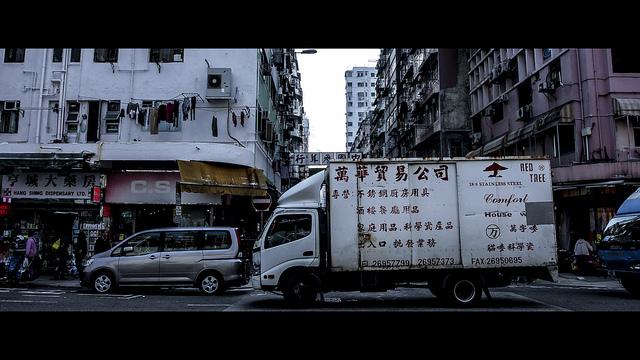Is the sign next to the truck in German?
Quick response, please. No. What is the business' name written on the back of the truck?
Concise answer only. Comfort. Does it look like it's summer?
Keep it brief. No. How many vehicles are in this image?
Answer briefly. 3. Do you think this is an American town?
Answer briefly. No. Is this a big truck?
Answer briefly. Yes. Is the writing in English?
Concise answer only. No. Is this a truck garbage collector?
Concise answer only. No. What color is the truck?
Quick response, please. White. Does this person need an umbrella?
Write a very short answer. No. Is that an American flag on the left side of the truck?
Give a very brief answer. No. What vehicle is this?
Be succinct. Truck. What number is on the sign?
Be succinct. 1. What is the lady riding?
Write a very short answer. Bike. Is this picture likely taken in an English- or non-English-speaking country?
Keep it brief. Non english. Do you see trees?
Write a very short answer. No. Where is this bus terminal?
Be succinct. Not here. Who wrote the quote?
Give a very brief answer. Red tree. Is there a truck?
Keep it brief. Yes. What is the name of the restaurant?
Write a very short answer. Cs. Is there a dog?
Give a very brief answer. No. What city is this in?
Short answer required. Tokyo. What is the company being advertise on the truck?
Keep it brief. Comfort. What mode of transportation is parked on the sidewalk?
Keep it brief. Van. 